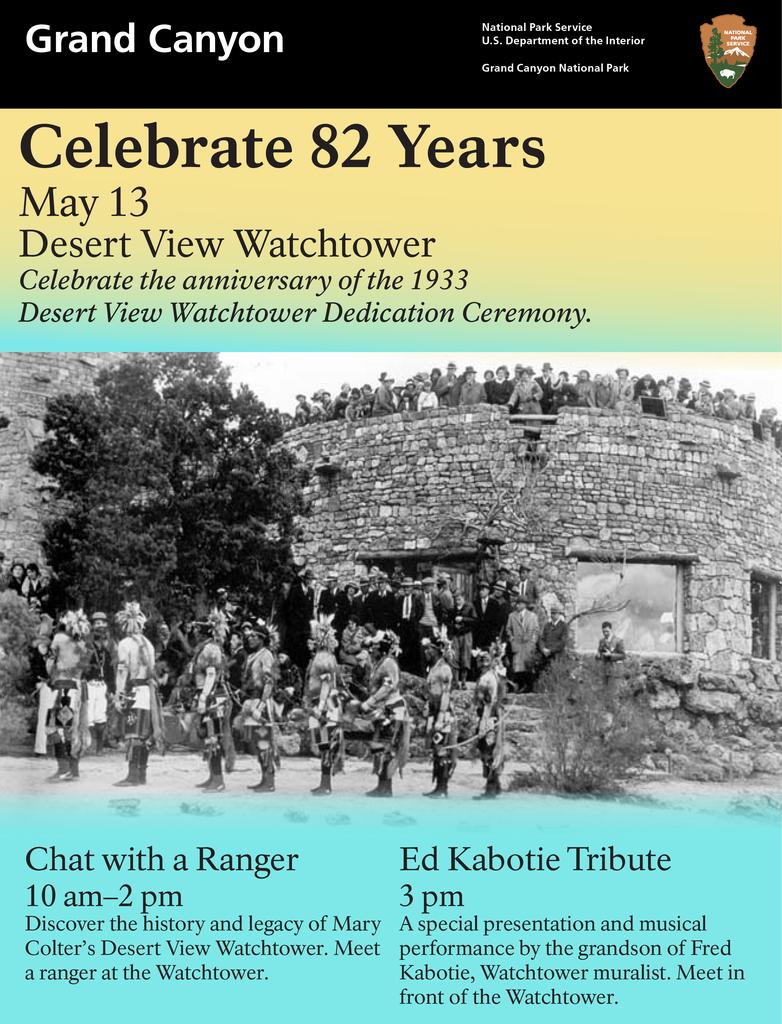How many years of celebration?
Offer a very short reply. 82. What time can you chat with a ranger?
Ensure brevity in your answer.  10am-2pm. 